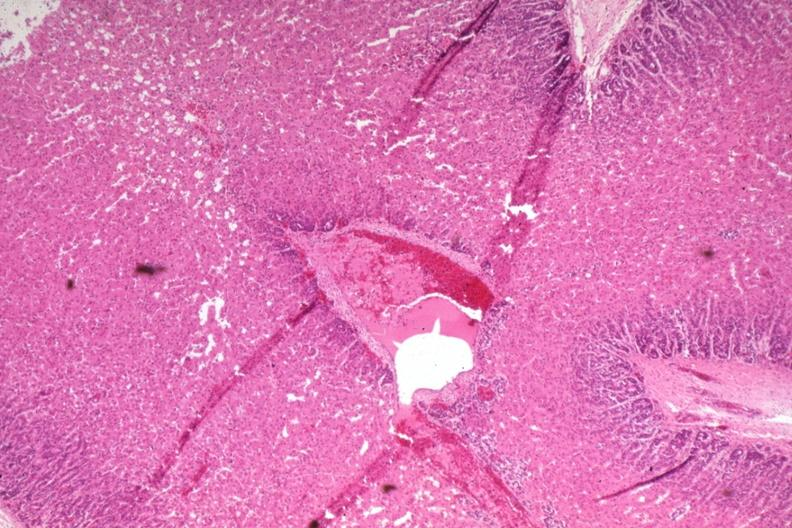s slide present?
Answer the question using a single word or phrase. No 